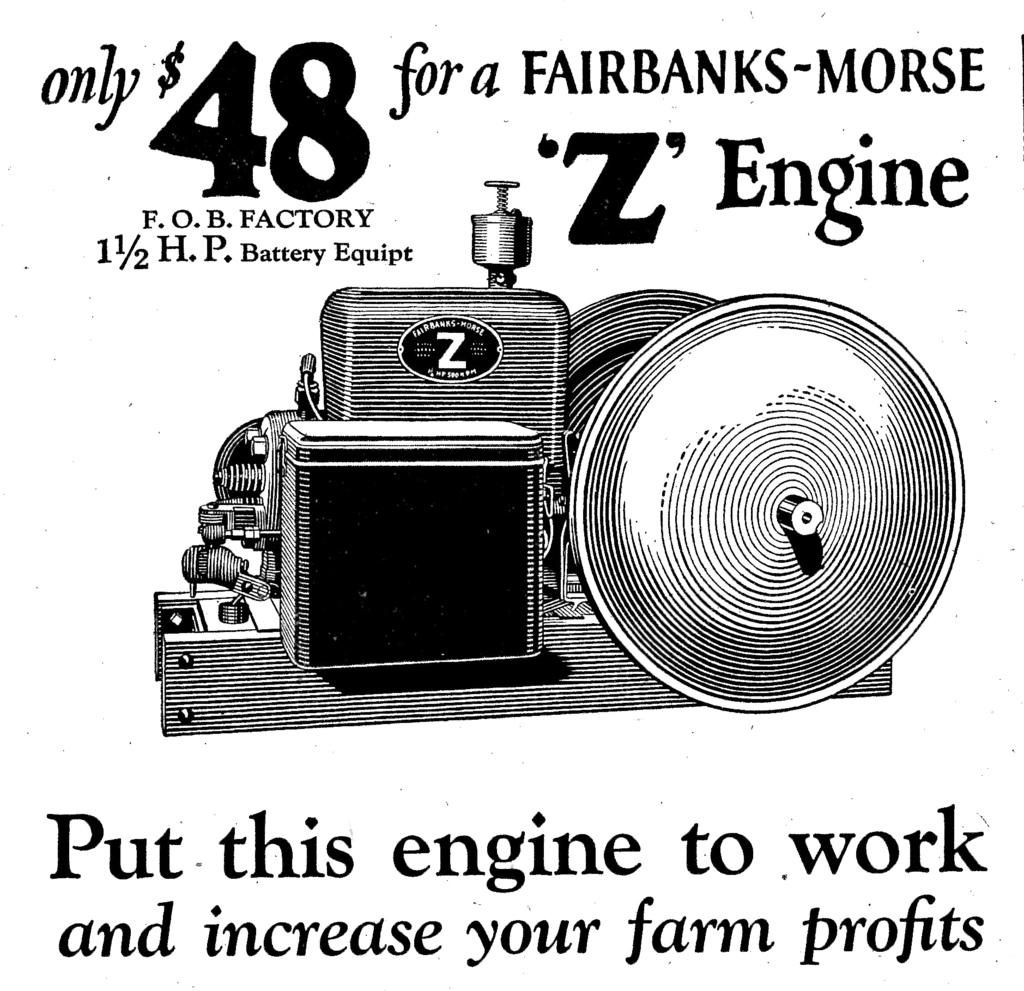What is the main subject of the image? There is an object in the image. What else can be seen in the image besides the object? There is text and numbers in the image. What is the color of the background in the image? The background of the image is white. What type of vessel is being destroyed in the image? There is no vessel or destruction present in the image; it only contains an object, text, numbers, and a white background. 